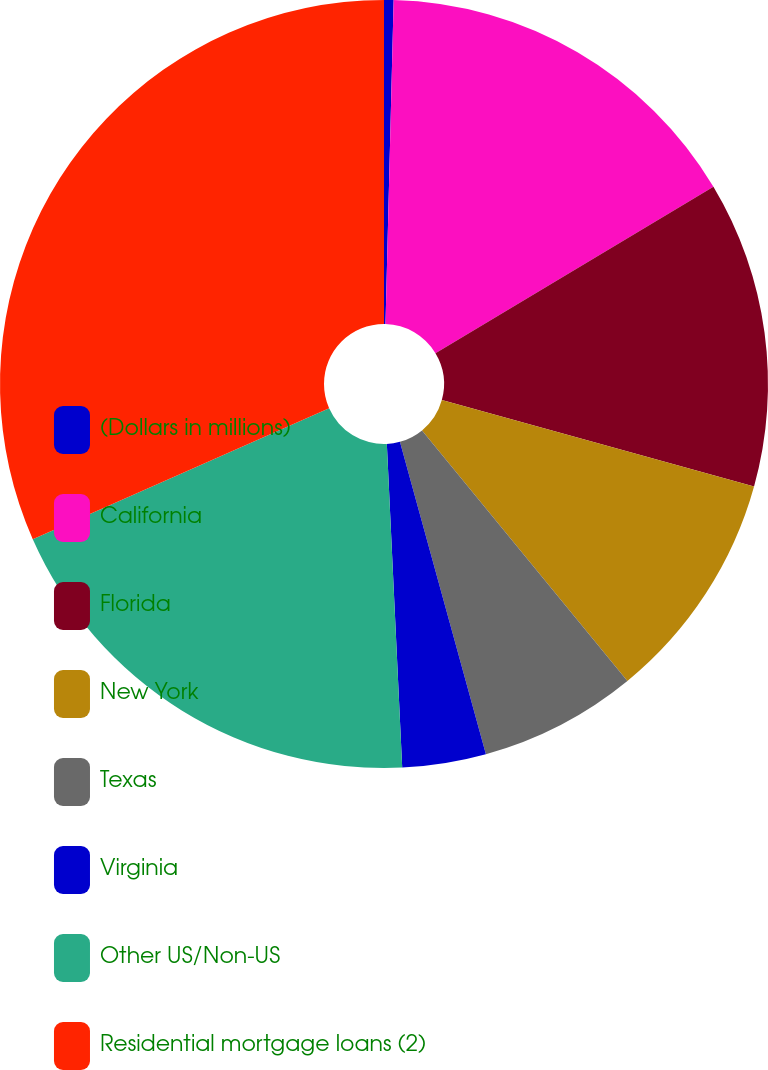Convert chart to OTSL. <chart><loc_0><loc_0><loc_500><loc_500><pie_chart><fcel>(Dollars in millions)<fcel>California<fcel>Florida<fcel>New York<fcel>Texas<fcel>Virginia<fcel>Other US/Non-US<fcel>Residential mortgage loans (2)<nl><fcel>0.4%<fcel>16.01%<fcel>12.89%<fcel>9.77%<fcel>6.65%<fcel>3.52%<fcel>19.13%<fcel>31.62%<nl></chart> 